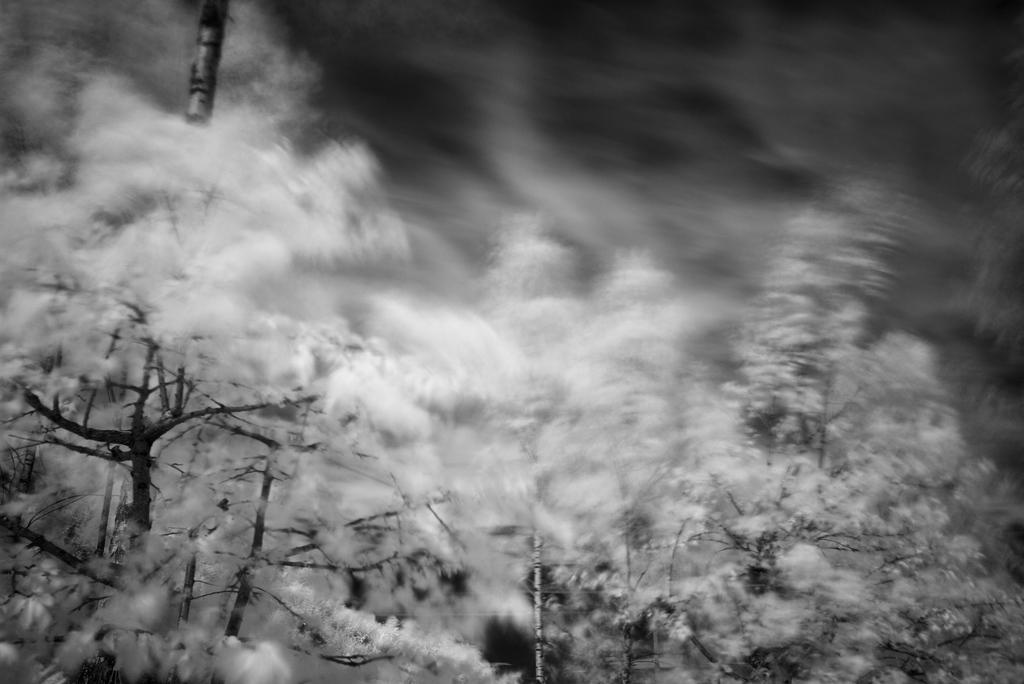What type of living organisms can be seen in the image? Plants can be seen in the image. What is the condition of the plants in the image? The plants have snow on them. What type of brake system can be seen on the plants in the image? There is no brake system present on the plants in the image. What type of cable is visible in the image? There is no cable visible in the image. 